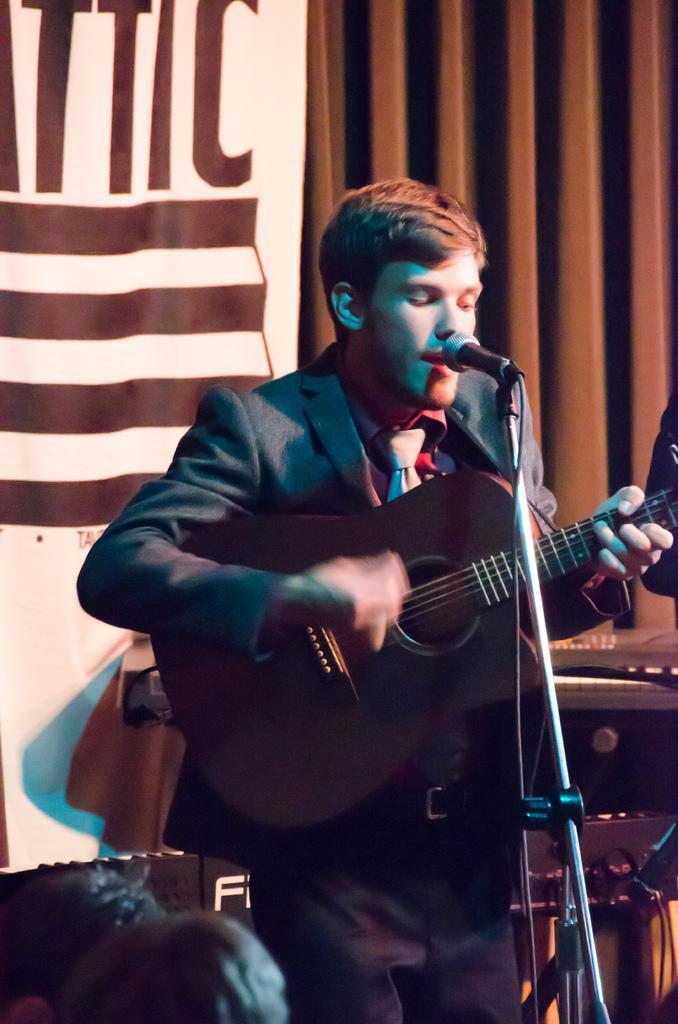Could you give a brief overview of what you see in this image? In this image I can see a man is holding a guitar. I can also see a mic in front of him. 